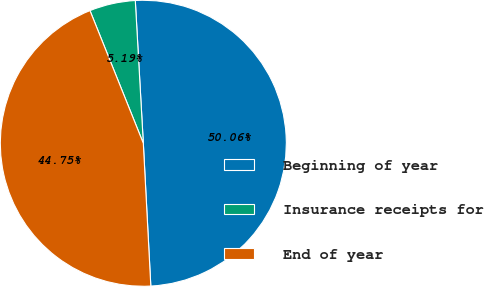<chart> <loc_0><loc_0><loc_500><loc_500><pie_chart><fcel>Beginning of year<fcel>Insurance receipts for<fcel>End of year<nl><fcel>50.06%<fcel>5.19%<fcel>44.75%<nl></chart> 